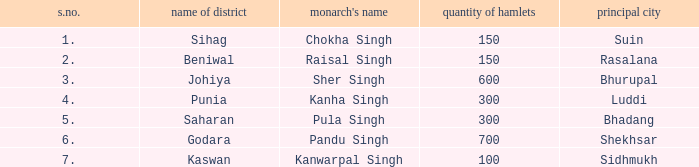What king has an S. number over 1 and a number of villages of 600? Sher Singh. 